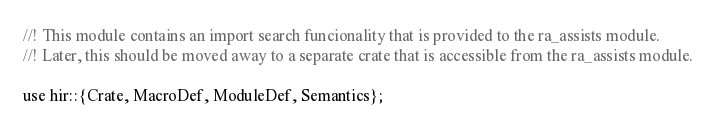<code> <loc_0><loc_0><loc_500><loc_500><_Rust_>//! This module contains an import search funcionality that is provided to the ra_assists module.
//! Later, this should be moved away to a separate crate that is accessible from the ra_assists module.

use hir::{Crate, MacroDef, ModuleDef, Semantics};</code> 